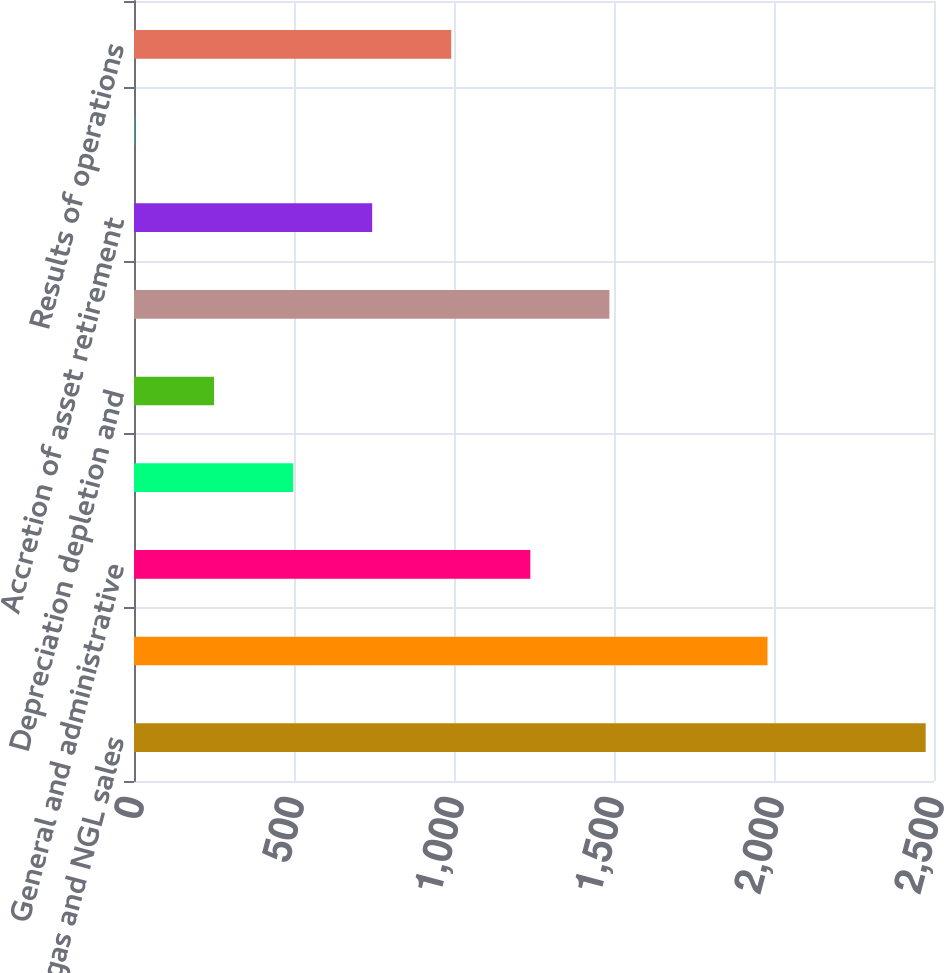<chart> <loc_0><loc_0><loc_500><loc_500><bar_chart><fcel>Oil gas and NGL sales<fcel>Lease operating expenses<fcel>General and administrative<fcel>Production and property taxes<fcel>Depreciation depletion and<fcel>Asset impairments<fcel>Accretion of asset retirement<fcel>Income tax benefit (expense)<fcel>Results of operations<nl><fcel>2474<fcel>1979.8<fcel>1238.5<fcel>497.2<fcel>250.1<fcel>1485.6<fcel>744.3<fcel>3<fcel>991.4<nl></chart> 